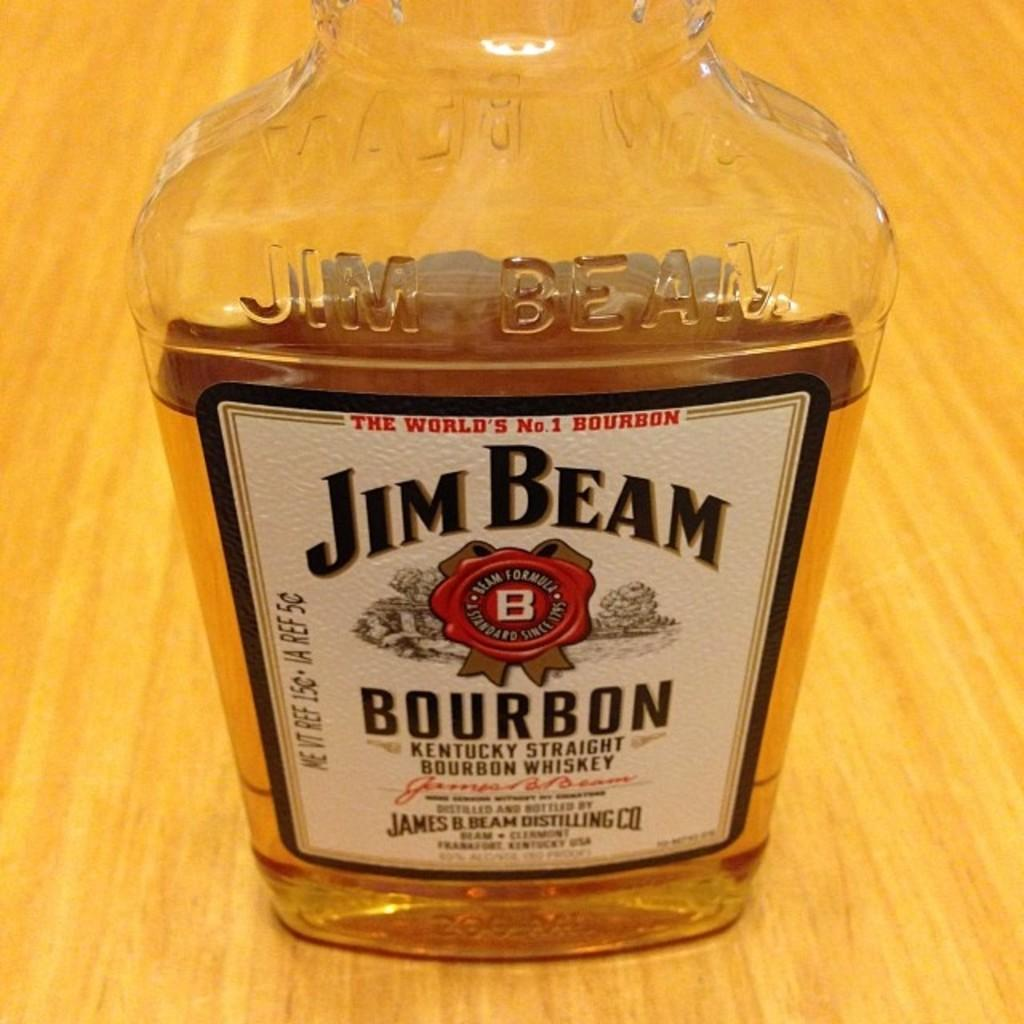Provide a one-sentence caption for the provided image. A close up of a half empty Jim Beam Burbon bottle. 